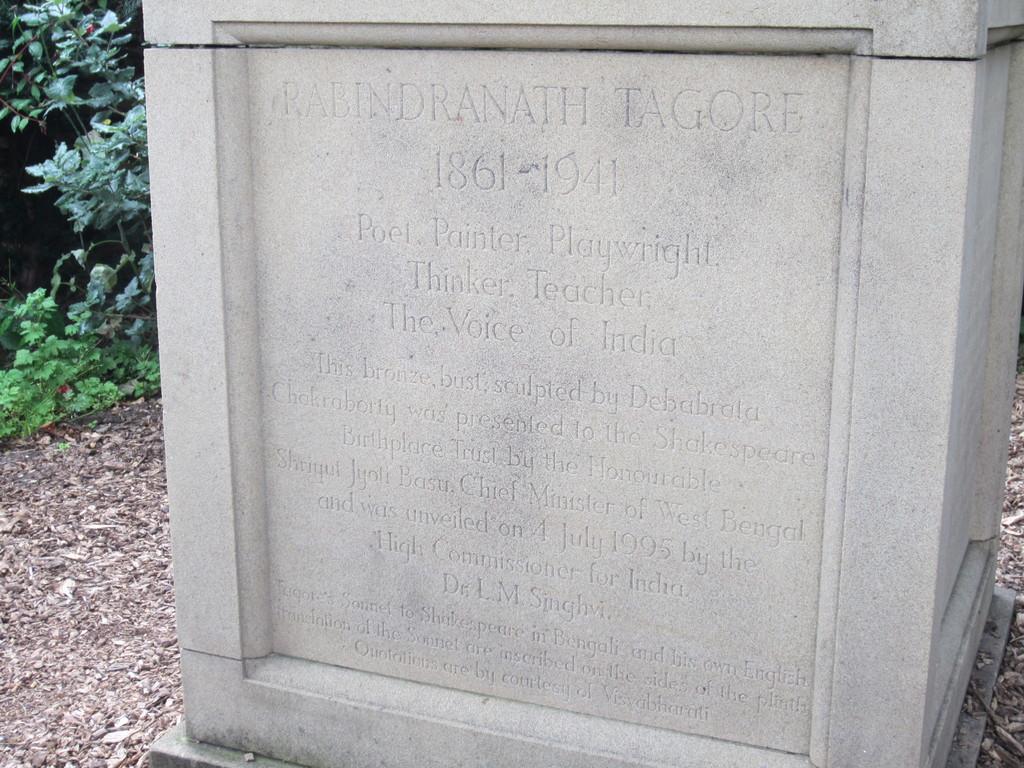In one or two sentences, can you explain what this image depicts? In the image there is a memorial stone and behind the stone there are plants. 